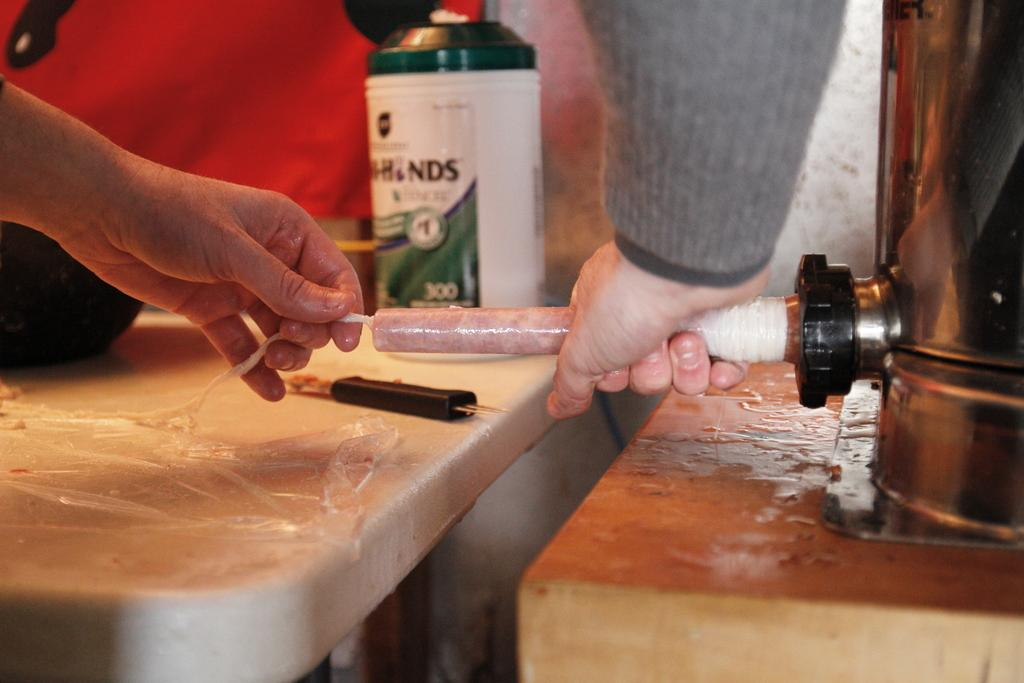<image>
Render a clear and concise summary of the photo. A canister with the number 300 on it and a person nearby. 